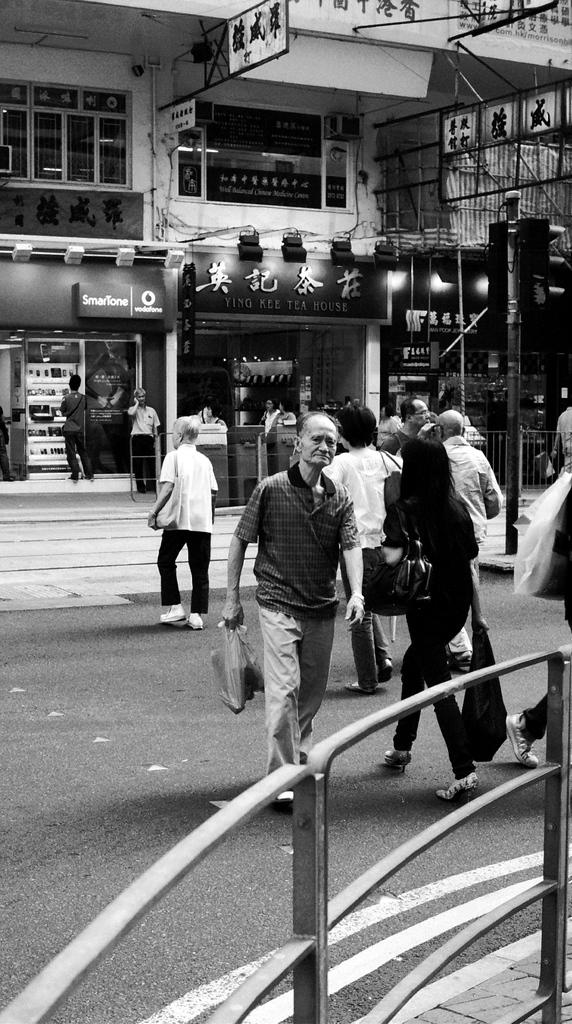What is the color scheme of the image? The image is black and white. What can be seen on the road in the image? There are persons on the road in the image. What object is present in the image that is typically used for support or signage? There is a pole in the image. What type of barrier is visible in the image? There is a fence in the image. What can be seen in the background of the image? There are boards and buildings visible in the background of the image. What type of tin can be seen in the image? There is no tin present in the image. 